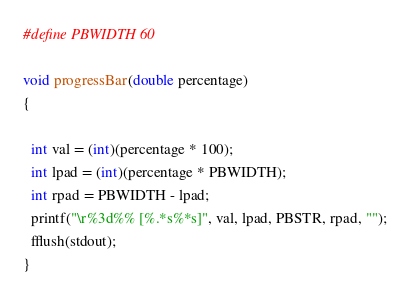<code> <loc_0><loc_0><loc_500><loc_500><_C++_>#define PBWIDTH 60

void progressBar(double percentage)
{

  int val = (int)(percentage * 100);
  int lpad = (int)(percentage * PBWIDTH);
  int rpad = PBWIDTH - lpad;
  printf("\r%3d%% [%.*s%*s]", val, lpad, PBSTR, rpad, "");
  fflush(stdout);
}
</code> 